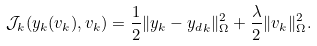<formula> <loc_0><loc_0><loc_500><loc_500>\mathcal { J } _ { k } ( y _ { k } ( v _ { k } ) , v _ { k } ) = \frac { 1 } { 2 } \| y _ { k } - { y _ { d } } _ { k } \| _ { \Omega } ^ { 2 } + \frac { \lambda } { 2 } \| v _ { k } \| _ { \Omega } ^ { 2 } .</formula> 